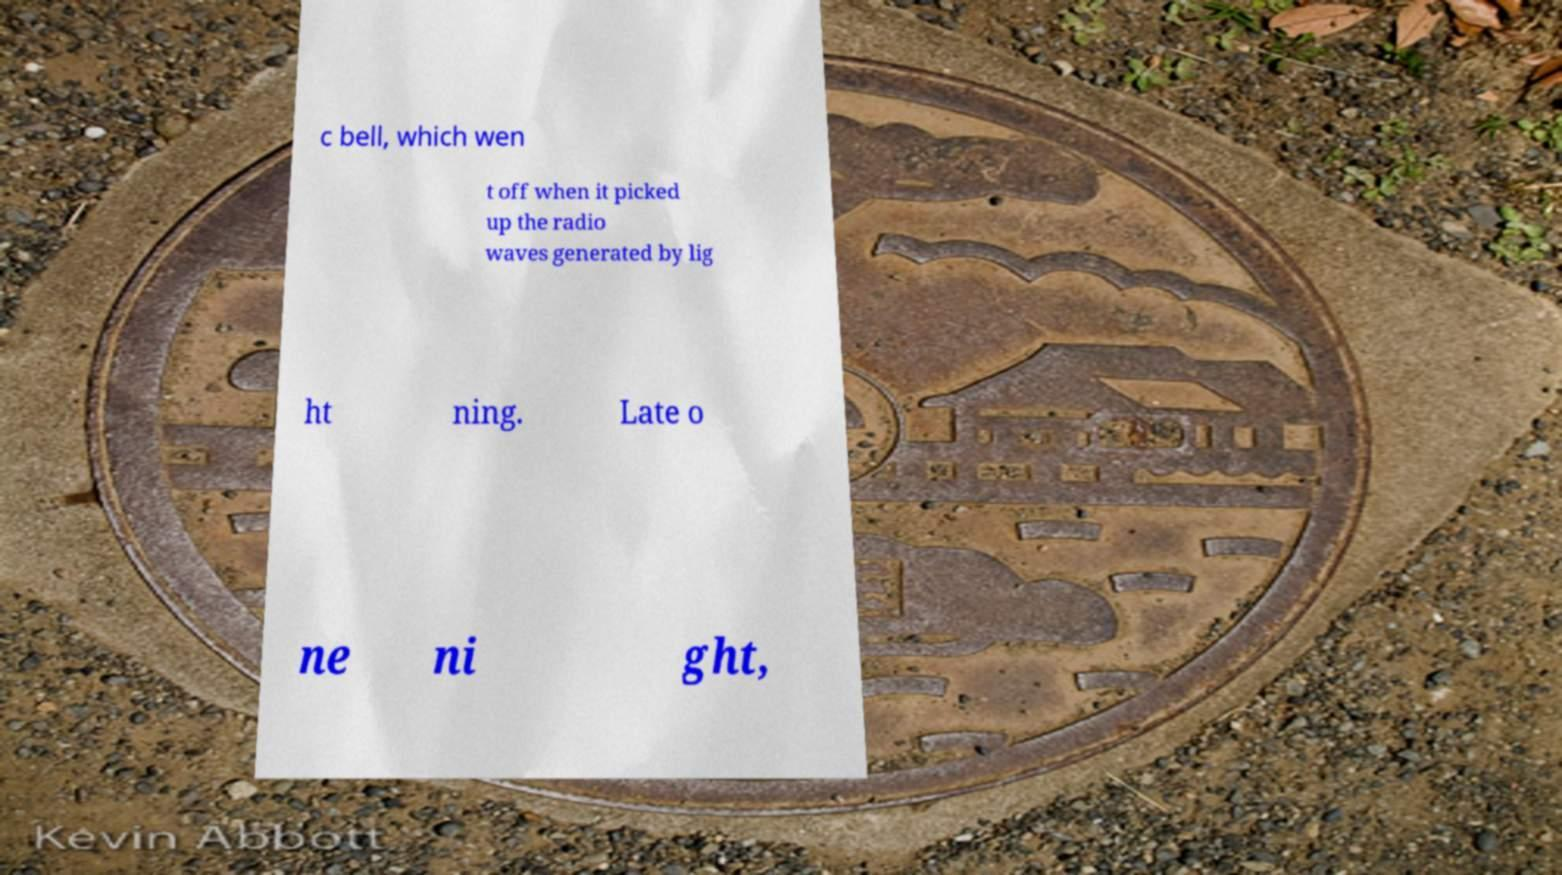Please identify and transcribe the text found in this image. c bell, which wen t off when it picked up the radio waves generated by lig ht ning. Late o ne ni ght, 